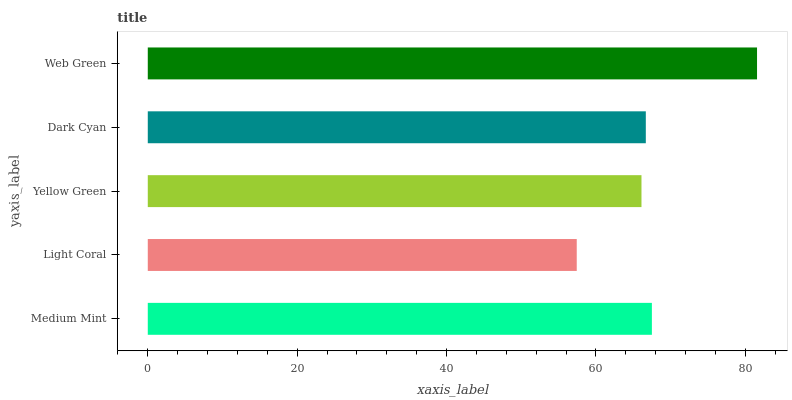Is Light Coral the minimum?
Answer yes or no. Yes. Is Web Green the maximum?
Answer yes or no. Yes. Is Yellow Green the minimum?
Answer yes or no. No. Is Yellow Green the maximum?
Answer yes or no. No. Is Yellow Green greater than Light Coral?
Answer yes or no. Yes. Is Light Coral less than Yellow Green?
Answer yes or no. Yes. Is Light Coral greater than Yellow Green?
Answer yes or no. No. Is Yellow Green less than Light Coral?
Answer yes or no. No. Is Dark Cyan the high median?
Answer yes or no. Yes. Is Dark Cyan the low median?
Answer yes or no. Yes. Is Yellow Green the high median?
Answer yes or no. No. Is Yellow Green the low median?
Answer yes or no. No. 